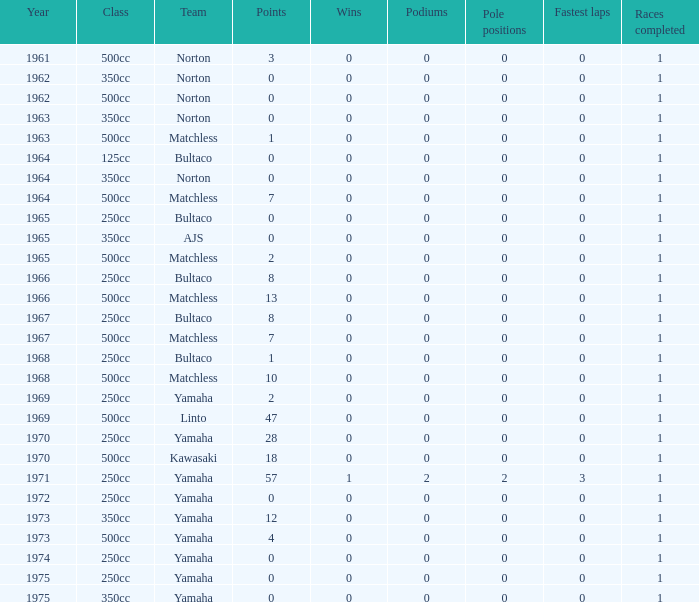Which class corresponds to more than 2 points, wins greater than 0, and a year earlier than 1973? 250cc. 